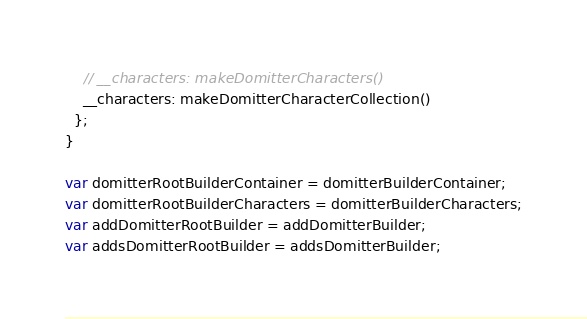<code> <loc_0><loc_0><loc_500><loc_500><_JavaScript_>    // __characters: makeDomitterCharacters()
    __characters: makeDomitterCharacterCollection()
  };
}

var domitterRootBuilderContainer = domitterBuilderContainer;
var domitterRootBuilderCharacters = domitterBuilderCharacters;
var addDomitterRootBuilder = addDomitterBuilder;
var addsDomitterRootBuilder = addsDomitterBuilder;
</code> 